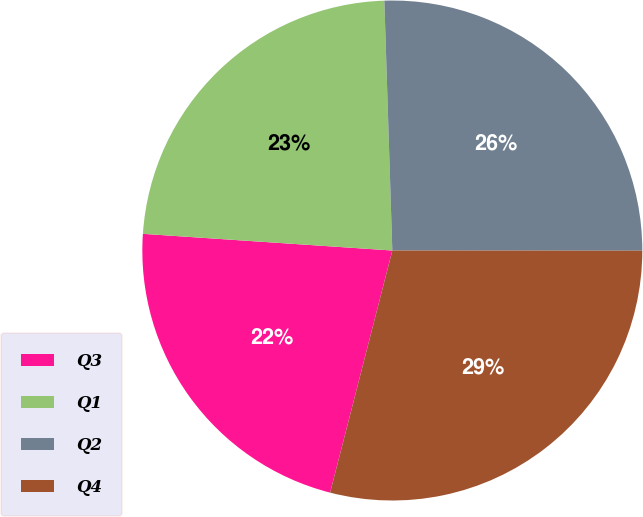Convert chart to OTSL. <chart><loc_0><loc_0><loc_500><loc_500><pie_chart><fcel>Q3<fcel>Q1<fcel>Q2<fcel>Q4<nl><fcel>22.06%<fcel>23.43%<fcel>25.52%<fcel>28.99%<nl></chart> 